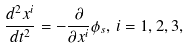Convert formula to latex. <formula><loc_0><loc_0><loc_500><loc_500>\frac { d ^ { 2 } x ^ { i } } { d t ^ { 2 } } = - \frac { \partial } { \partial x ^ { i } } \phi _ { s } , \, i = 1 , 2 , 3 ,</formula> 